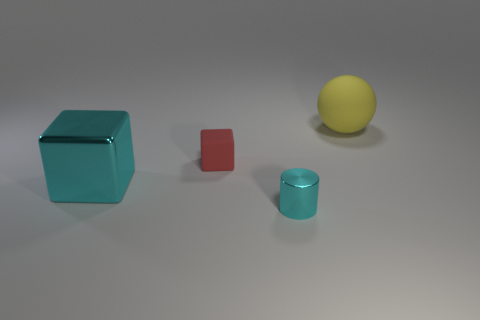Add 3 small gray metallic blocks. How many objects exist? 7 Subtract all red cubes. How many cubes are left? 1 Subtract all balls. How many objects are left? 3 Subtract 1 blocks. How many blocks are left? 1 Add 3 yellow rubber spheres. How many yellow rubber spheres exist? 4 Subtract 0 red cylinders. How many objects are left? 4 Subtract all blue balls. Subtract all gray blocks. How many balls are left? 1 Subtract all large yellow matte objects. Subtract all tiny cyan cylinders. How many objects are left? 2 Add 4 yellow rubber things. How many yellow rubber things are left? 5 